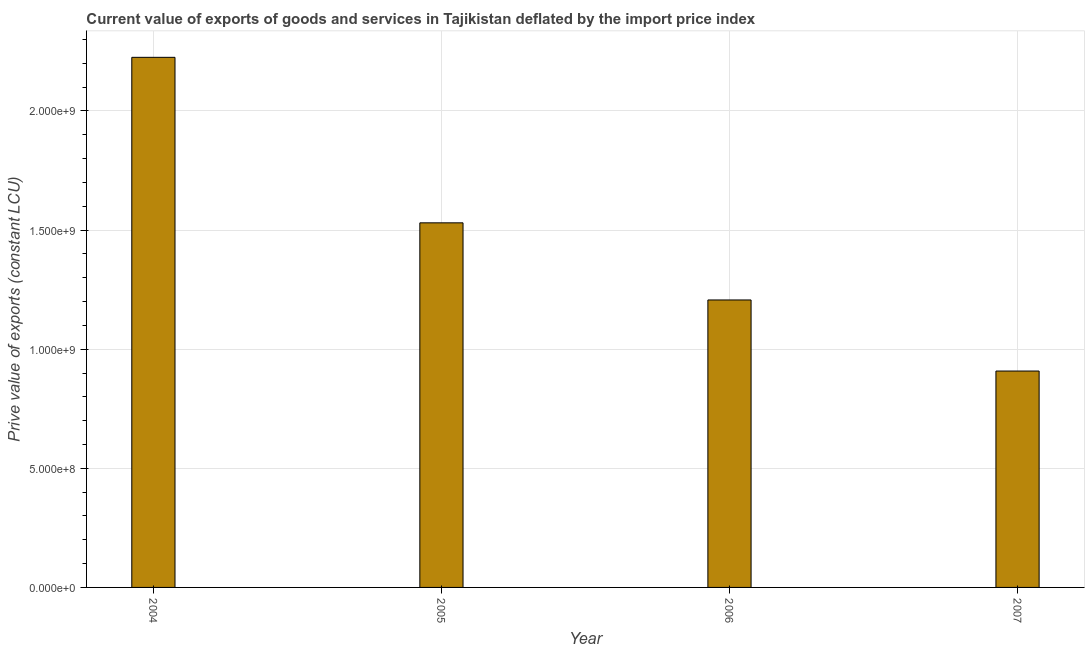Does the graph contain any zero values?
Offer a terse response. No. What is the title of the graph?
Give a very brief answer. Current value of exports of goods and services in Tajikistan deflated by the import price index. What is the label or title of the Y-axis?
Provide a succinct answer. Prive value of exports (constant LCU). What is the price value of exports in 2006?
Provide a succinct answer. 1.21e+09. Across all years, what is the maximum price value of exports?
Make the answer very short. 2.22e+09. Across all years, what is the minimum price value of exports?
Ensure brevity in your answer.  9.08e+08. In which year was the price value of exports minimum?
Ensure brevity in your answer.  2007. What is the sum of the price value of exports?
Keep it short and to the point. 5.87e+09. What is the difference between the price value of exports in 2005 and 2006?
Your response must be concise. 3.24e+08. What is the average price value of exports per year?
Offer a very short reply. 1.47e+09. What is the median price value of exports?
Offer a terse response. 1.37e+09. Do a majority of the years between 2006 and 2005 (inclusive) have price value of exports greater than 1800000000 LCU?
Ensure brevity in your answer.  No. What is the ratio of the price value of exports in 2005 to that in 2007?
Offer a very short reply. 1.69. What is the difference between the highest and the second highest price value of exports?
Offer a very short reply. 6.95e+08. Is the sum of the price value of exports in 2004 and 2007 greater than the maximum price value of exports across all years?
Keep it short and to the point. Yes. What is the difference between the highest and the lowest price value of exports?
Provide a short and direct response. 1.32e+09. How many years are there in the graph?
Ensure brevity in your answer.  4. Are the values on the major ticks of Y-axis written in scientific E-notation?
Your response must be concise. Yes. What is the Prive value of exports (constant LCU) of 2004?
Ensure brevity in your answer.  2.22e+09. What is the Prive value of exports (constant LCU) of 2005?
Offer a terse response. 1.53e+09. What is the Prive value of exports (constant LCU) in 2006?
Provide a succinct answer. 1.21e+09. What is the Prive value of exports (constant LCU) in 2007?
Offer a very short reply. 9.08e+08. What is the difference between the Prive value of exports (constant LCU) in 2004 and 2005?
Give a very brief answer. 6.95e+08. What is the difference between the Prive value of exports (constant LCU) in 2004 and 2006?
Ensure brevity in your answer.  1.02e+09. What is the difference between the Prive value of exports (constant LCU) in 2004 and 2007?
Make the answer very short. 1.32e+09. What is the difference between the Prive value of exports (constant LCU) in 2005 and 2006?
Keep it short and to the point. 3.24e+08. What is the difference between the Prive value of exports (constant LCU) in 2005 and 2007?
Provide a short and direct response. 6.22e+08. What is the difference between the Prive value of exports (constant LCU) in 2006 and 2007?
Your answer should be compact. 2.98e+08. What is the ratio of the Prive value of exports (constant LCU) in 2004 to that in 2005?
Give a very brief answer. 1.45. What is the ratio of the Prive value of exports (constant LCU) in 2004 to that in 2006?
Your response must be concise. 1.84. What is the ratio of the Prive value of exports (constant LCU) in 2004 to that in 2007?
Provide a short and direct response. 2.45. What is the ratio of the Prive value of exports (constant LCU) in 2005 to that in 2006?
Offer a terse response. 1.27. What is the ratio of the Prive value of exports (constant LCU) in 2005 to that in 2007?
Your answer should be very brief. 1.69. What is the ratio of the Prive value of exports (constant LCU) in 2006 to that in 2007?
Make the answer very short. 1.33. 